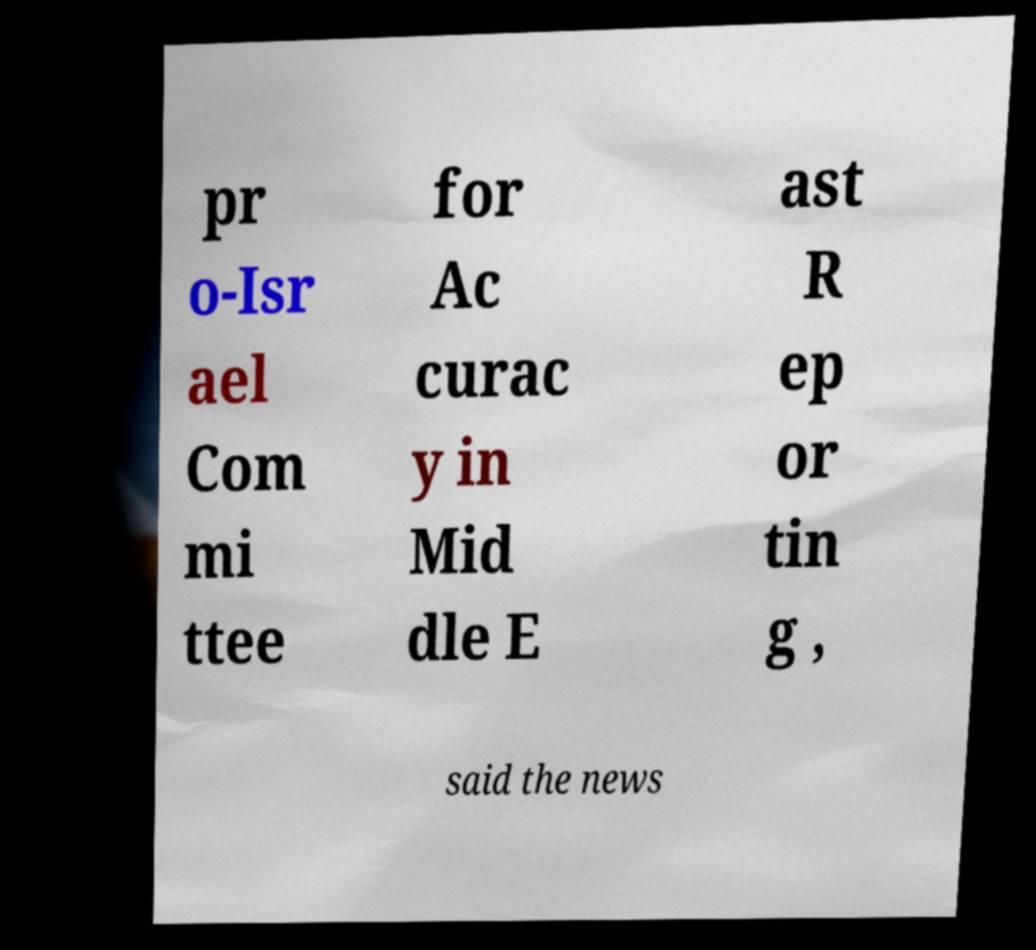I need the written content from this picture converted into text. Can you do that? pr o-Isr ael Com mi ttee for Ac curac y in Mid dle E ast R ep or tin g , said the news 